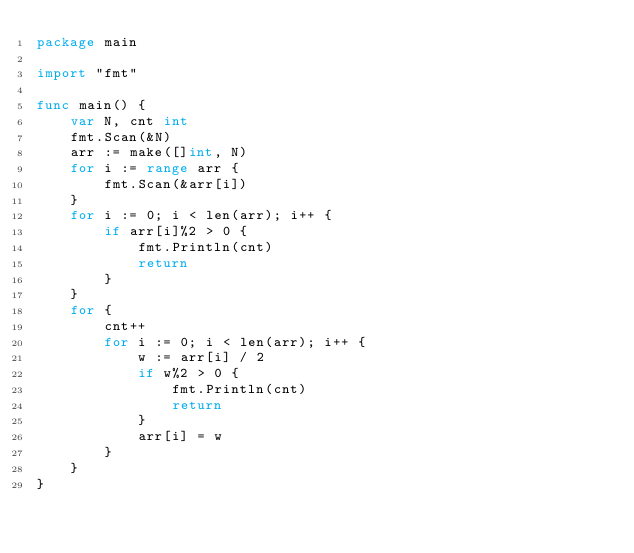<code> <loc_0><loc_0><loc_500><loc_500><_Go_>package main

import "fmt"

func main() {
	var N, cnt int
	fmt.Scan(&N)
	arr := make([]int, N)
	for i := range arr {
		fmt.Scan(&arr[i])
	}
	for i := 0; i < len(arr); i++ {
		if arr[i]%2 > 0 {
			fmt.Println(cnt)
			return
		}
	}
	for {
		cnt++
		for i := 0; i < len(arr); i++ {
			w := arr[i] / 2
			if w%2 > 0 {
				fmt.Println(cnt)
				return
			}
			arr[i] = w
		}
	}
}</code> 